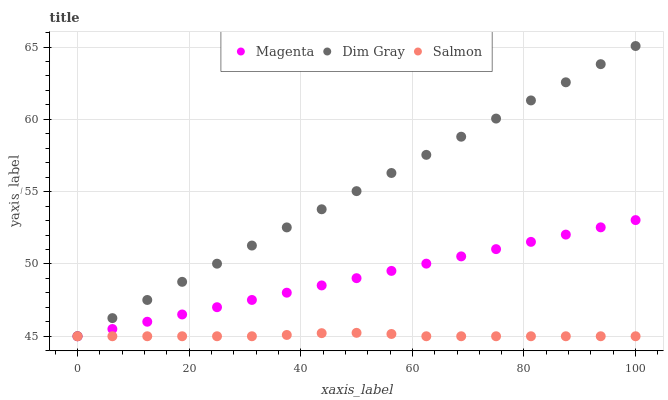Does Salmon have the minimum area under the curve?
Answer yes or no. Yes. Does Dim Gray have the maximum area under the curve?
Answer yes or no. Yes. Does Dim Gray have the minimum area under the curve?
Answer yes or no. No. Does Salmon have the maximum area under the curve?
Answer yes or no. No. Is Magenta the smoothest?
Answer yes or no. Yes. Is Salmon the roughest?
Answer yes or no. Yes. Is Dim Gray the smoothest?
Answer yes or no. No. Is Dim Gray the roughest?
Answer yes or no. No. Does Magenta have the lowest value?
Answer yes or no. Yes. Does Dim Gray have the highest value?
Answer yes or no. Yes. Does Salmon have the highest value?
Answer yes or no. No. Does Salmon intersect Magenta?
Answer yes or no. Yes. Is Salmon less than Magenta?
Answer yes or no. No. Is Salmon greater than Magenta?
Answer yes or no. No. 